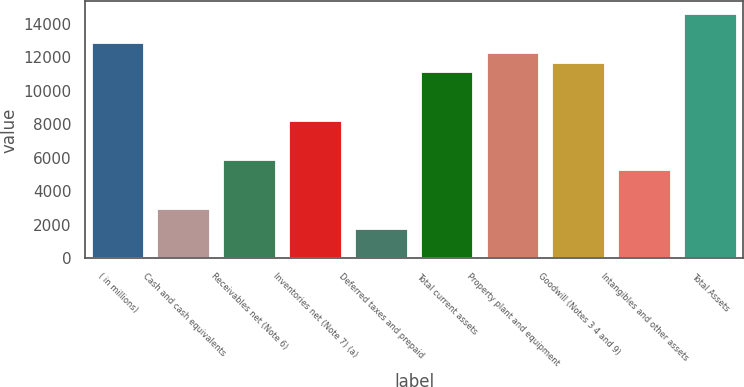Convert chart. <chart><loc_0><loc_0><loc_500><loc_500><bar_chart><fcel>( in millions)<fcel>Cash and cash equivalents<fcel>Receivables net (Note 6)<fcel>Inventories net (Note 7) (a)<fcel>Deferred taxes and prepaid<fcel>Total current assets<fcel>Property plant and equipment<fcel>Goodwill (Notes 3 4 and 9)<fcel>Intangibles and other assets<fcel>Total Assets<nl><fcel>12848.8<fcel>2920.95<fcel>5840.9<fcel>8176.86<fcel>1752.97<fcel>11096.8<fcel>12264.8<fcel>11680.8<fcel>5256.91<fcel>14600.8<nl></chart> 